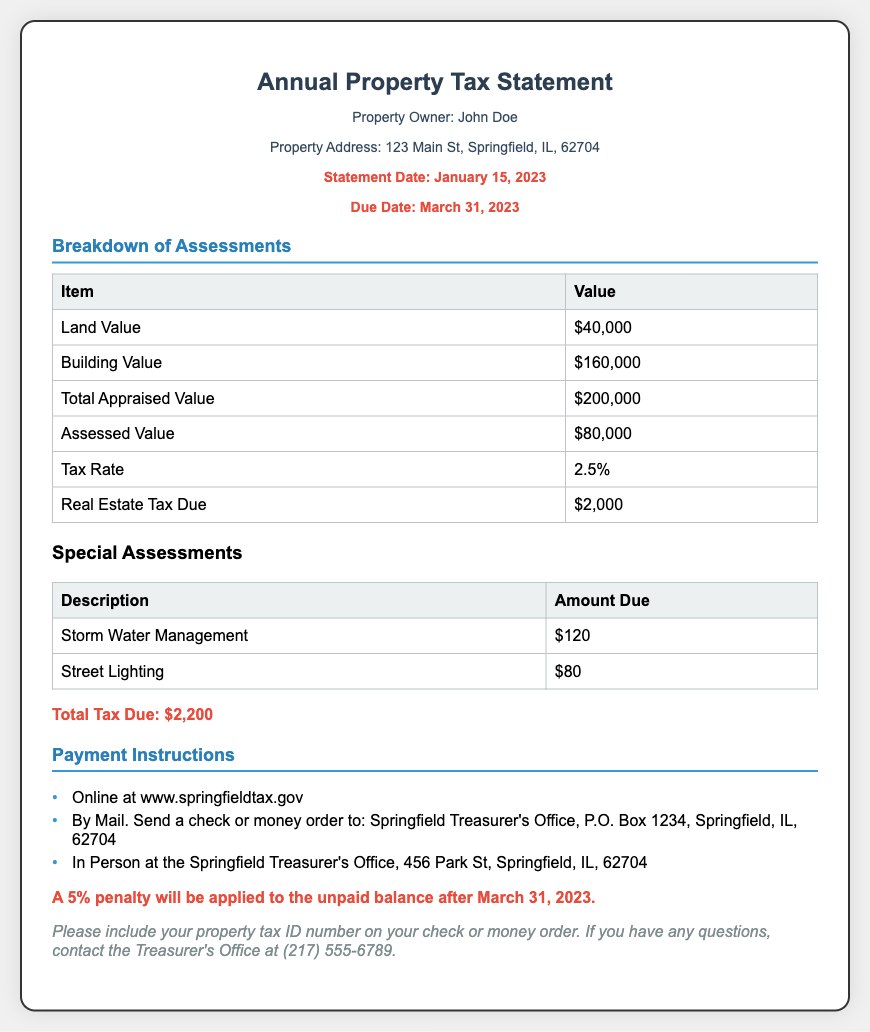what is the statement date? The statement date is specified in the document as January 15, 2023.
Answer: January 15, 2023 what is the property owner's name? The property owner's name is listed at the top of the document as John Doe.
Answer: John Doe what is the total tax due? The total tax due is calculated from the breakdown of assessments and listed as $2,200.
Answer: $2,200 what is the assessed value of the property? The assessed value can be found in the breakdown of assessments as $80,000.
Answer: $80,000 what is the due date for the payment? The due date for the payment is noted as March 31, 2023.
Answer: March 31, 2023 what penalties apply if the balance is unpaid? The document states that a 5% penalty will be applied to the unpaid balance after the due date.
Answer: 5% how can I pay the property tax? The options for payment are listed in the payment instructions section of the document.
Answer: Online, By Mail, In Person what is the tax rate applied to the property? The tax rate is specified in the breakdown of assessments as 2.5%.
Answer: 2.5% what is the address of the property? The property address is indicated in the document as 123 Main St, Springfield, IL, 62704.
Answer: 123 Main St, Springfield, IL, 62704 